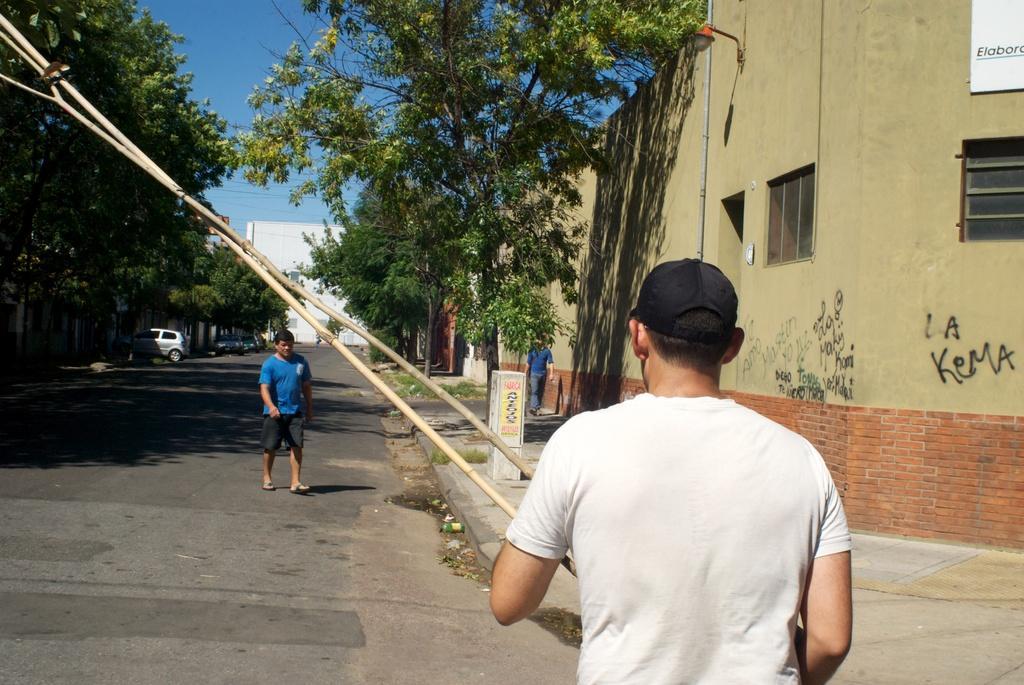Please provide a concise description of this image. In this image I can see few buildings,glass windows,trees and few vehicles on the road. I can see few people walking. The sky is in blue color. 